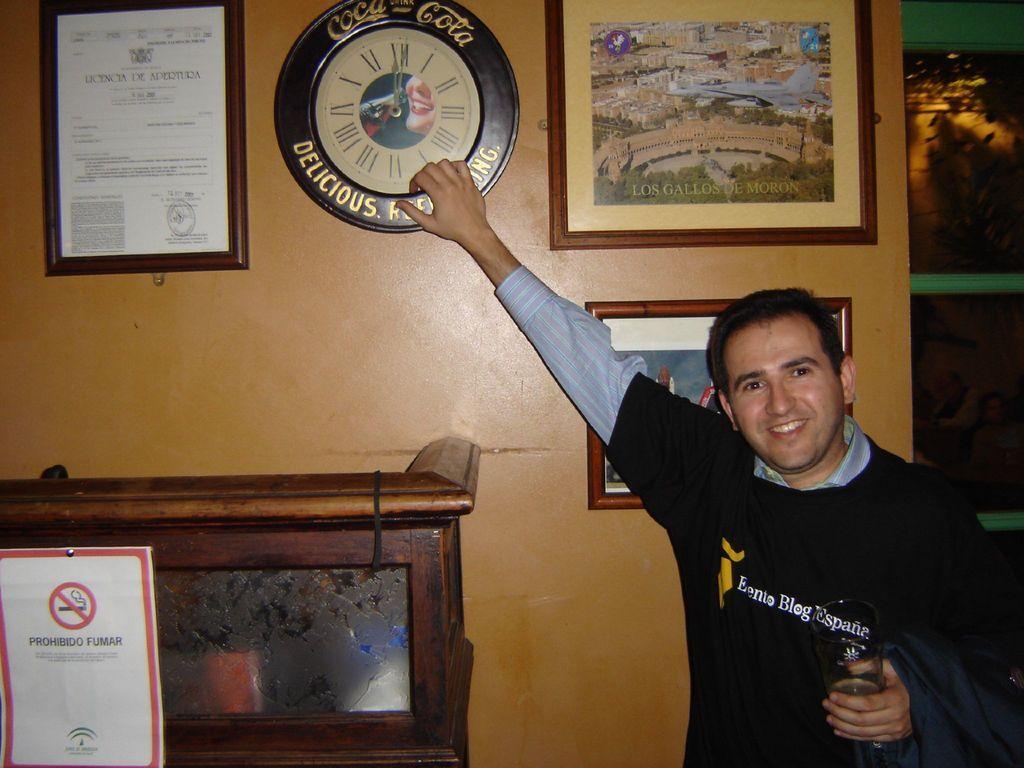Can you describe this image briefly? In the image there is a man standing on right side in black t-shirt holding glass in one hand and holding a watch in another hand which is on wall with photo frames on either side of it and a cupboard below it with a caution board on it. 